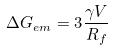<formula> <loc_0><loc_0><loc_500><loc_500>\Delta G _ { e m } = 3 \frac { \gamma V } { R _ { f } }</formula> 